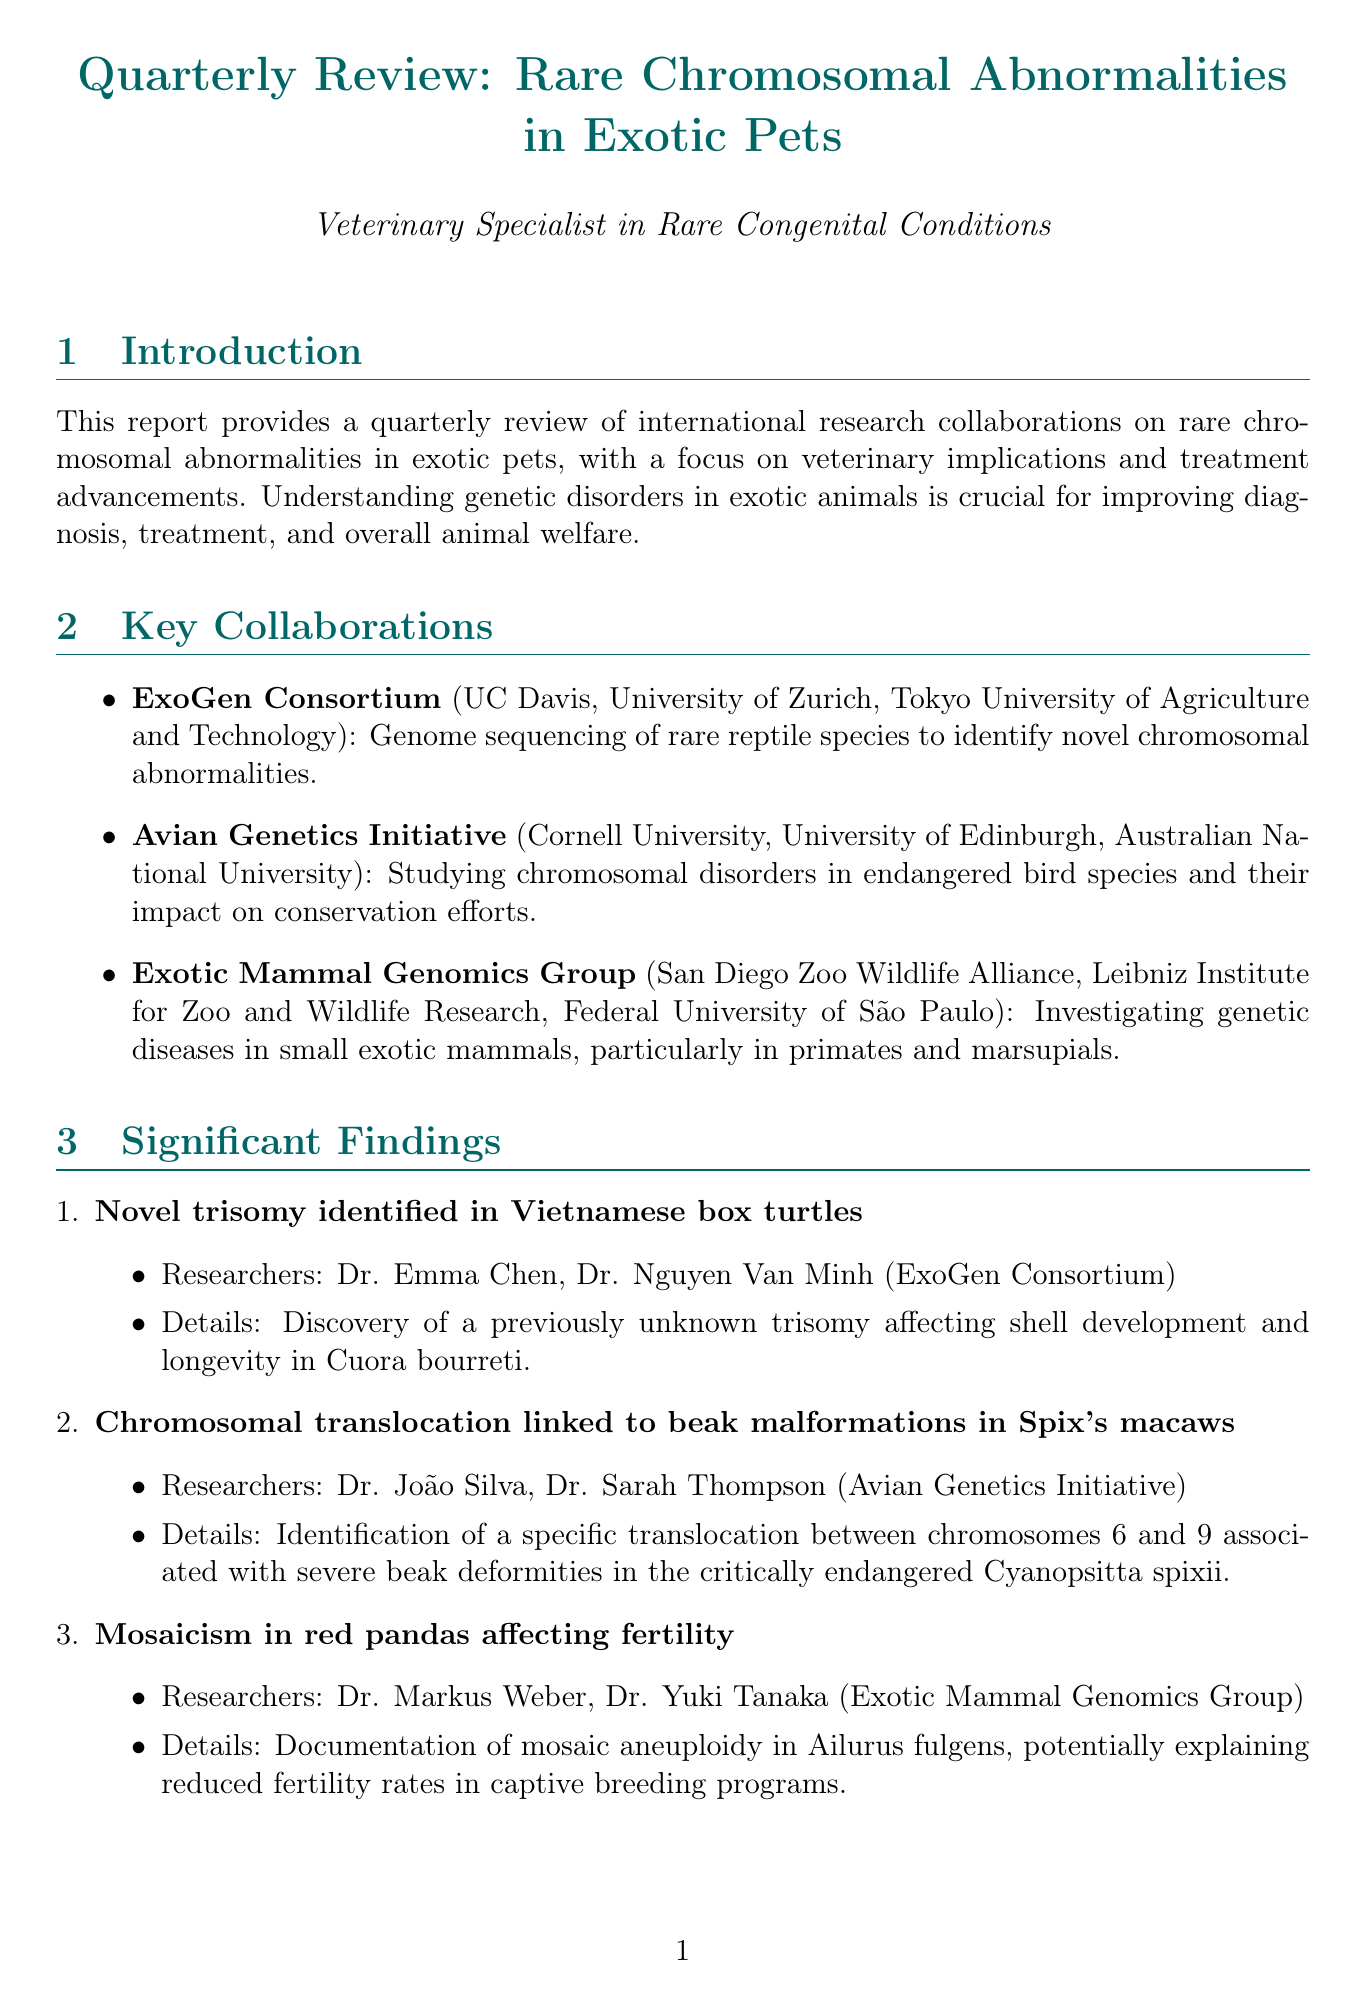What is the focus of the ExoGen Consortium? The focus of the ExoGen Consortium is genome sequencing of rare reptile species to identify novel chromosomal abnormalities.
Answer: Genome sequencing of rare reptile species What significant finding is linked to Spix's macaws? The significant finding linked to Spix's macaws is a chromosomal translocation associated with severe beak deformities.
Answer: Chromosomal translocation associated with severe beak deformities Who are the researchers involved in the novel trisomy identified in Vietnamese box turtles? The researchers involved in the novel trisomy identified in Vietnamese box turtles are Dr. Emma Chen and Dr. Nguyen Van Minh.
Answer: Dr. Emma Chen, Dr. Nguyen Van Minh What is one of the future directions mentioned in the report? One of the future directions mentioned in the report is exploring CRISPR-Cas9 technology to correct genetic abnormalities in embryos.
Answer: Exploring CRISPR-Cas9 technology What is the potential impact of non-invasive diagnostics? The potential impact of non-invasive diagnostics would greatly improve early detection and treatment in fragile exotic species.
Answer: Greatly improve early detection and treatment What ethical consideration is mentioned in the challenges? The ethical consideration mentioned in the challenges is ethical considerations in genetic research on endangered animals.
Answer: Ethical considerations in genetic research What is a veterinary implication for diagnosis? A veterinary implication for diagnosis is improved genetic testing protocols for exotic pets.
Answer: Improved genetic testing protocols Which institution is part of the Avian Genetics Initiative? Cornell University is part of the Avian Genetics Initiative.
Answer: Cornell University 